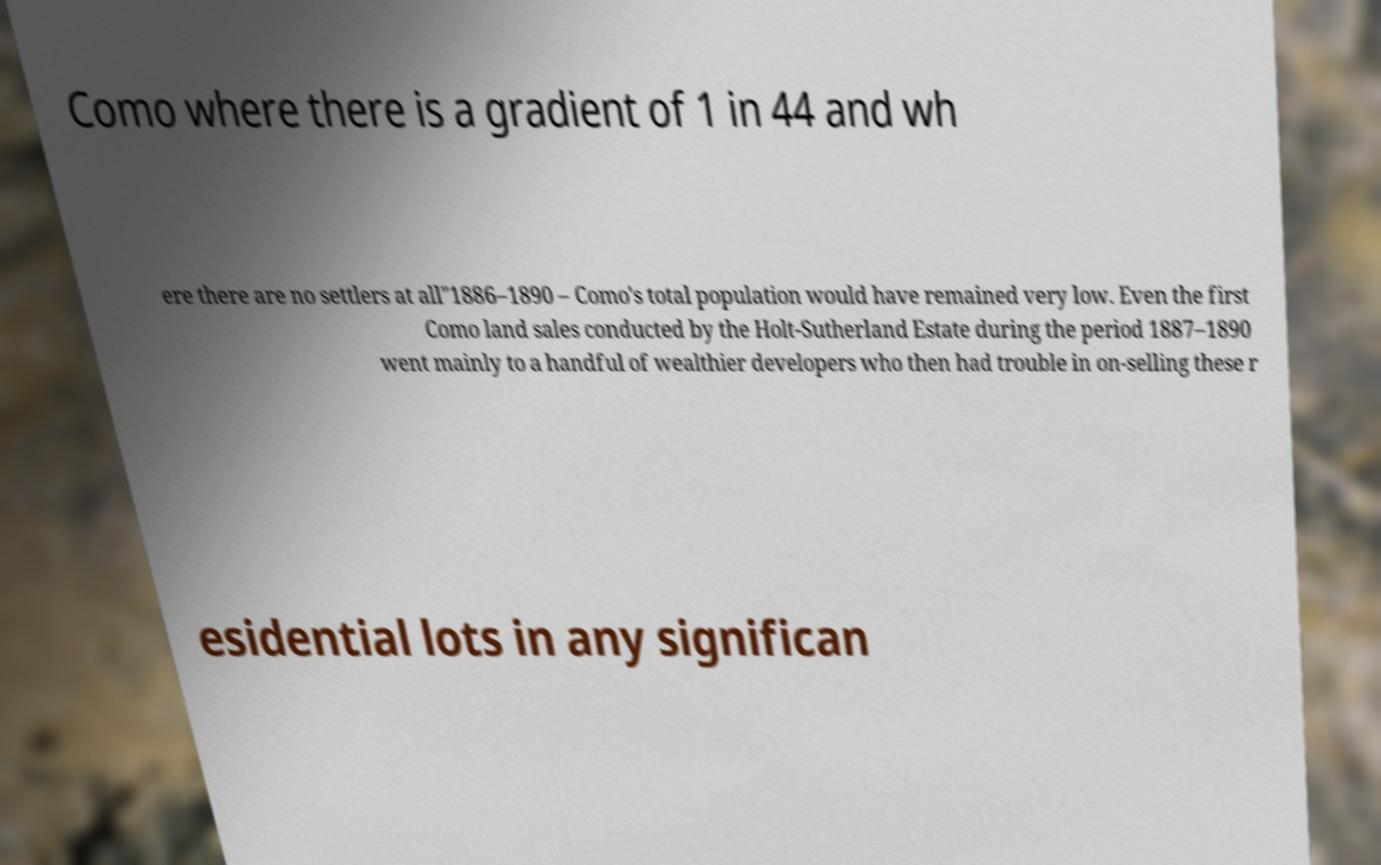Could you extract and type out the text from this image? Como where there is a gradient of 1 in 44 and wh ere there are no settlers at all"1886–1890 – Como's total population would have remained very low. Even the first Como land sales conducted by the Holt-Sutherland Estate during the period 1887–1890 went mainly to a handful of wealthier developers who then had trouble in on-selling these r esidential lots in any significan 